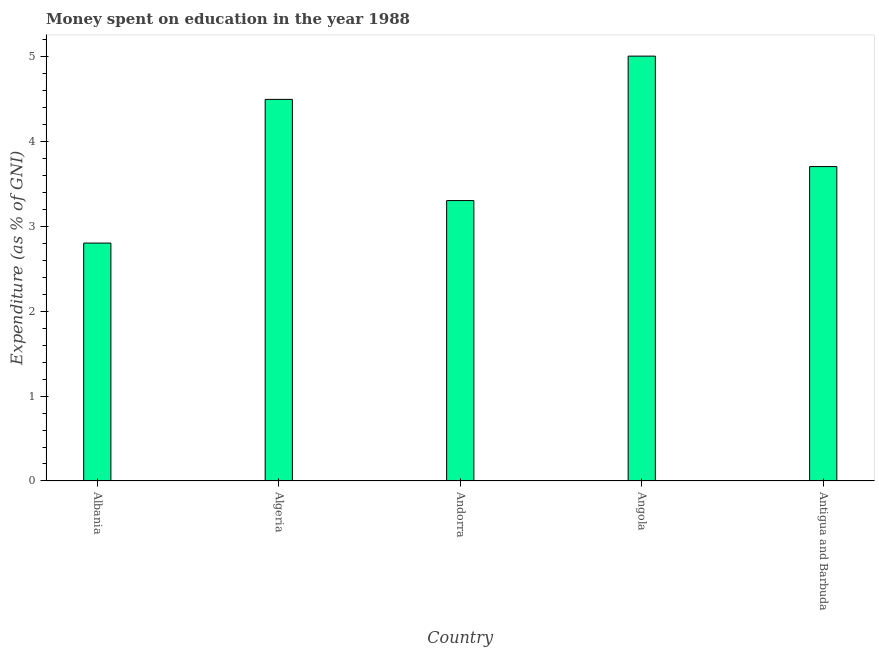Does the graph contain any zero values?
Your answer should be very brief. No. What is the title of the graph?
Offer a terse response. Money spent on education in the year 1988. What is the label or title of the X-axis?
Provide a succinct answer. Country. What is the label or title of the Y-axis?
Offer a very short reply. Expenditure (as % of GNI). Across all countries, what is the maximum expenditure on education?
Your answer should be very brief. 5. In which country was the expenditure on education maximum?
Make the answer very short. Angola. In which country was the expenditure on education minimum?
Ensure brevity in your answer.  Albania. What is the sum of the expenditure on education?
Your response must be concise. 19.29. What is the difference between the expenditure on education in Algeria and Andorra?
Keep it short and to the point. 1.19. What is the average expenditure on education per country?
Offer a very short reply. 3.86. What is the median expenditure on education?
Your response must be concise. 3.7. What is the ratio of the expenditure on education in Albania to that in Antigua and Barbuda?
Ensure brevity in your answer.  0.76. Is the difference between the expenditure on education in Albania and Algeria greater than the difference between any two countries?
Ensure brevity in your answer.  No. What is the difference between the highest and the second highest expenditure on education?
Your answer should be very brief. 0.51. What is the difference between the highest and the lowest expenditure on education?
Offer a very short reply. 2.2. How many bars are there?
Your answer should be very brief. 5. Are all the bars in the graph horizontal?
Ensure brevity in your answer.  No. What is the difference between two consecutive major ticks on the Y-axis?
Ensure brevity in your answer.  1. What is the Expenditure (as % of GNI) in Albania?
Keep it short and to the point. 2.8. What is the Expenditure (as % of GNI) in Algeria?
Provide a short and direct response. 4.49. What is the Expenditure (as % of GNI) of Angola?
Offer a very short reply. 5. What is the Expenditure (as % of GNI) of Antigua and Barbuda?
Your response must be concise. 3.7. What is the difference between the Expenditure (as % of GNI) in Albania and Algeria?
Your response must be concise. -1.69. What is the difference between the Expenditure (as % of GNI) in Albania and Andorra?
Give a very brief answer. -0.5. What is the difference between the Expenditure (as % of GNI) in Algeria and Andorra?
Give a very brief answer. 1.19. What is the difference between the Expenditure (as % of GNI) in Algeria and Angola?
Provide a succinct answer. -0.51. What is the difference between the Expenditure (as % of GNI) in Algeria and Antigua and Barbuda?
Your response must be concise. 0.79. What is the difference between the Expenditure (as % of GNI) in Andorra and Angola?
Offer a very short reply. -1.7. What is the ratio of the Expenditure (as % of GNI) in Albania to that in Algeria?
Provide a succinct answer. 0.62. What is the ratio of the Expenditure (as % of GNI) in Albania to that in Andorra?
Ensure brevity in your answer.  0.85. What is the ratio of the Expenditure (as % of GNI) in Albania to that in Angola?
Offer a terse response. 0.56. What is the ratio of the Expenditure (as % of GNI) in Albania to that in Antigua and Barbuda?
Ensure brevity in your answer.  0.76. What is the ratio of the Expenditure (as % of GNI) in Algeria to that in Andorra?
Provide a succinct answer. 1.36. What is the ratio of the Expenditure (as % of GNI) in Algeria to that in Angola?
Ensure brevity in your answer.  0.9. What is the ratio of the Expenditure (as % of GNI) in Algeria to that in Antigua and Barbuda?
Your answer should be very brief. 1.21. What is the ratio of the Expenditure (as % of GNI) in Andorra to that in Angola?
Give a very brief answer. 0.66. What is the ratio of the Expenditure (as % of GNI) in Andorra to that in Antigua and Barbuda?
Ensure brevity in your answer.  0.89. What is the ratio of the Expenditure (as % of GNI) in Angola to that in Antigua and Barbuda?
Keep it short and to the point. 1.35. 